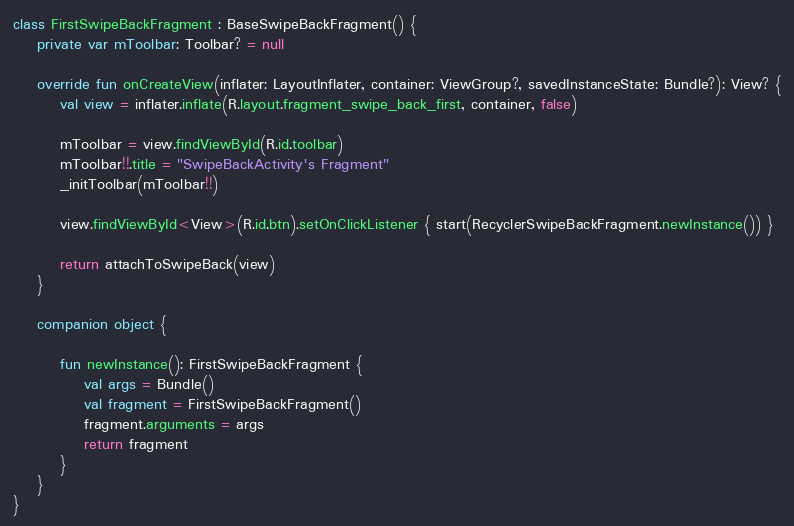<code> <loc_0><loc_0><loc_500><loc_500><_Kotlin_>class FirstSwipeBackFragment : BaseSwipeBackFragment() {
    private var mToolbar: Toolbar? = null

    override fun onCreateView(inflater: LayoutInflater, container: ViewGroup?, savedInstanceState: Bundle?): View? {
        val view = inflater.inflate(R.layout.fragment_swipe_back_first, container, false)

        mToolbar = view.findViewById(R.id.toolbar)
        mToolbar!!.title = "SwipeBackActivity's Fragment"
        _initToolbar(mToolbar!!)

        view.findViewById<View>(R.id.btn).setOnClickListener { start(RecyclerSwipeBackFragment.newInstance()) }

        return attachToSwipeBack(view)
    }

    companion object {

        fun newInstance(): FirstSwipeBackFragment {
            val args = Bundle()
            val fragment = FirstSwipeBackFragment()
            fragment.arguments = args
            return fragment
        }
    }
}
</code> 